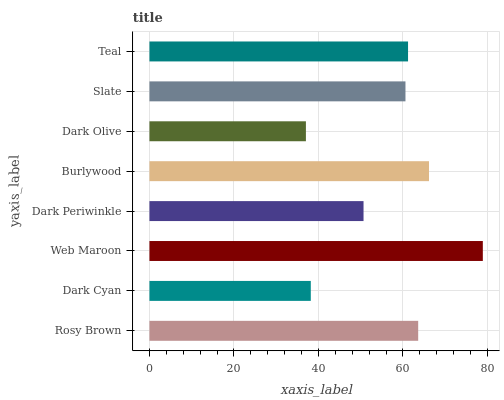Is Dark Olive the minimum?
Answer yes or no. Yes. Is Web Maroon the maximum?
Answer yes or no. Yes. Is Dark Cyan the minimum?
Answer yes or no. No. Is Dark Cyan the maximum?
Answer yes or no. No. Is Rosy Brown greater than Dark Cyan?
Answer yes or no. Yes. Is Dark Cyan less than Rosy Brown?
Answer yes or no. Yes. Is Dark Cyan greater than Rosy Brown?
Answer yes or no. No. Is Rosy Brown less than Dark Cyan?
Answer yes or no. No. Is Teal the high median?
Answer yes or no. Yes. Is Slate the low median?
Answer yes or no. Yes. Is Slate the high median?
Answer yes or no. No. Is Dark Olive the low median?
Answer yes or no. No. 